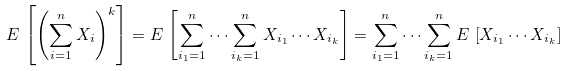Convert formula to latex. <formula><loc_0><loc_0><loc_500><loc_500>E \, \left [ \left ( \sum _ { i = 1 } ^ { n } X _ { i } \right ) ^ { k } \right ] = E \, \left [ \sum _ { i _ { 1 } = 1 } ^ { n } \cdots \sum _ { i _ { k } = 1 } ^ { n } X _ { i _ { 1 } } \cdots X _ { i _ { k } } \right ] = \sum _ { i _ { 1 } = 1 } ^ { n } \cdots \sum _ { i _ { k } = 1 } ^ { n } E \, \left [ X _ { i _ { 1 } } \cdots X _ { i _ { k } } \right ]</formula> 